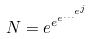Convert formula to latex. <formula><loc_0><loc_0><loc_500><loc_500>N = e ^ { e ^ { e ^ { \dots ^ { e ^ { j } } } } }</formula> 